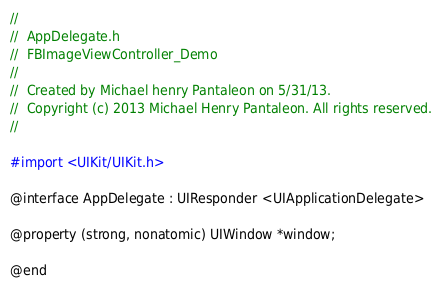<code> <loc_0><loc_0><loc_500><loc_500><_C_>//
//  AppDelegate.h
//  FBImageViewController_Demo
//
//  Created by Michael henry Pantaleon on 5/31/13.
//  Copyright (c) 2013 Michael Henry Pantaleon. All rights reserved.
//

#import <UIKit/UIKit.h>

@interface AppDelegate : UIResponder <UIApplicationDelegate>

@property (strong, nonatomic) UIWindow *window;

@end
</code> 